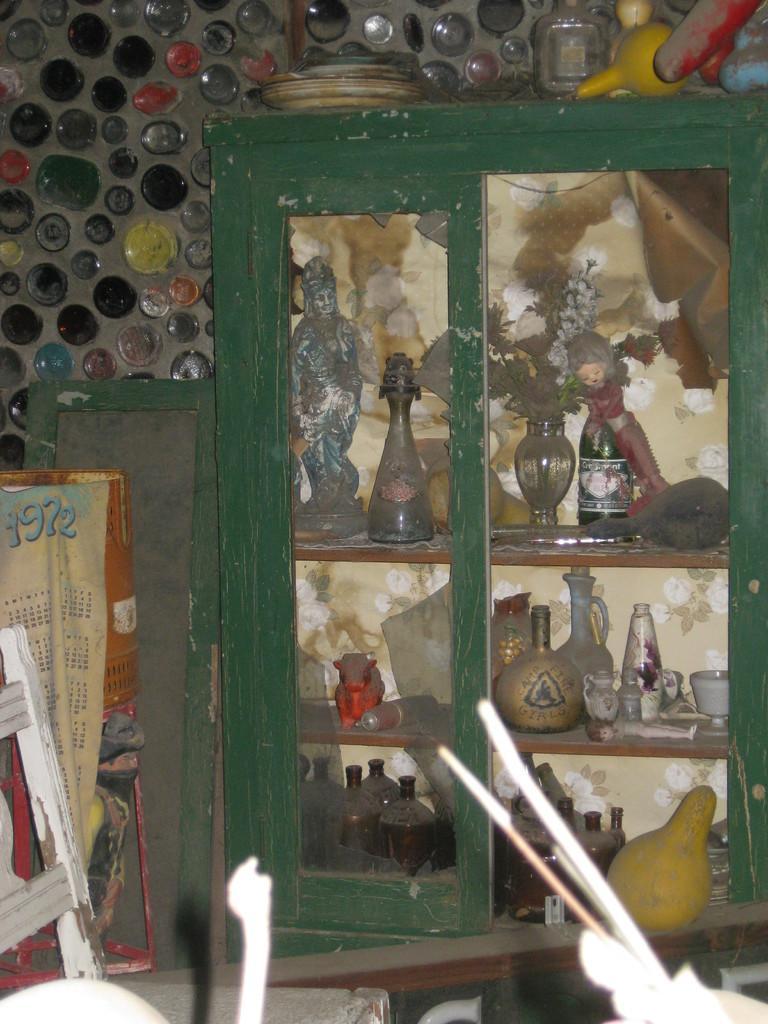How would you summarize this image in a sentence or two? In the image there are many jars,jugs and flower vase in the cupboard with many jars and plates above it, the back wall is made of glasses, in the front the is some furniture. 